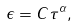<formula> <loc_0><loc_0><loc_500><loc_500>\epsilon = C \tau ^ { \alpha } ,</formula> 